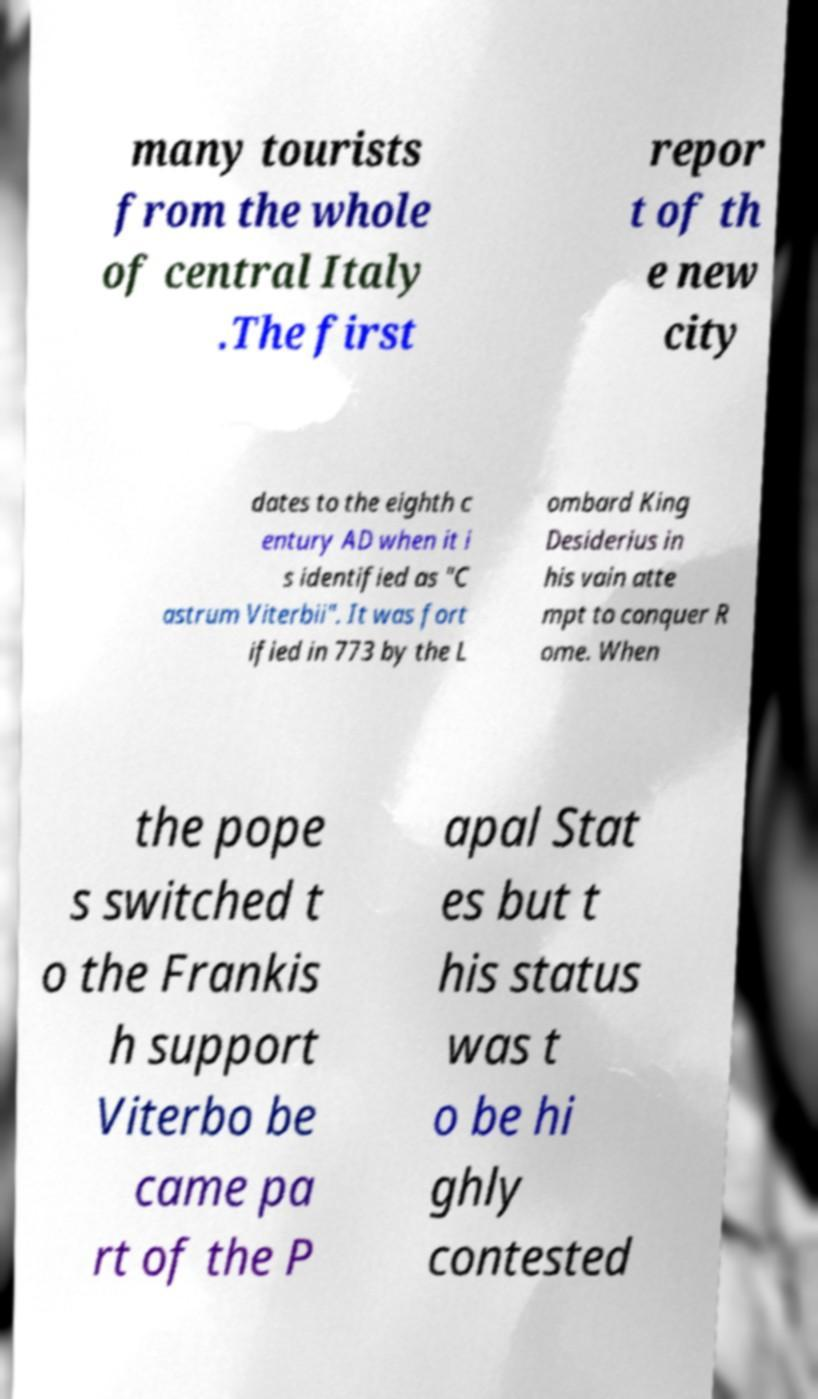What messages or text are displayed in this image? I need them in a readable, typed format. many tourists from the whole of central Italy .The first repor t of th e new city dates to the eighth c entury AD when it i s identified as "C astrum Viterbii". It was fort ified in 773 by the L ombard King Desiderius in his vain atte mpt to conquer R ome. When the pope s switched t o the Frankis h support Viterbo be came pa rt of the P apal Stat es but t his status was t o be hi ghly contested 